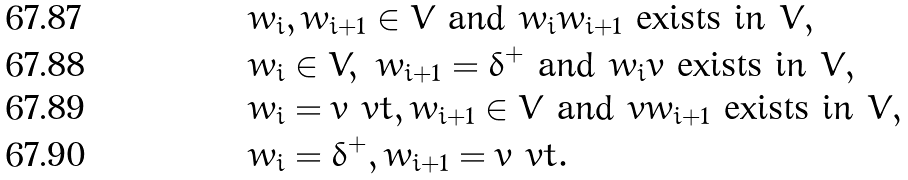<formula> <loc_0><loc_0><loc_500><loc_500>& w _ { i } , w _ { i + 1 } \in V \text { and } w _ { i } w _ { i + 1 } \text { exists in $V$} , \\ & w _ { i } \in V , \ w _ { i + 1 } = \delta ^ { + } \text { and } w _ { i } v \text { exists in $V$} , \\ & w _ { i } = v ^ { \ } v t , w _ { i + 1 } \in V \text { and } v w _ { i + 1 } \text { exists in $V$} , \\ & w _ { i } = \delta ^ { + } , w _ { i + 1 } = v ^ { \ } v t .</formula> 